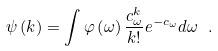Convert formula to latex. <formula><loc_0><loc_0><loc_500><loc_500>\psi \left ( k \right ) = \int \varphi \left ( \omega \right ) \frac { c _ { \omega } ^ { k } } { k ! } e ^ { - c _ { \omega } } d \omega \ .</formula> 